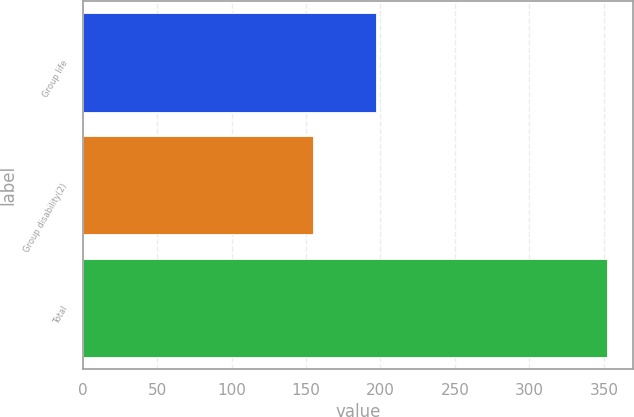Convert chart. <chart><loc_0><loc_0><loc_500><loc_500><bar_chart><fcel>Group life<fcel>Group disability(2)<fcel>Total<nl><fcel>197<fcel>155<fcel>352<nl></chart> 